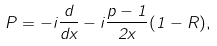<formula> <loc_0><loc_0><loc_500><loc_500>P = - i \frac { d } { d x } - i \frac { p - 1 } { 2 x } ( 1 - R ) ,</formula> 